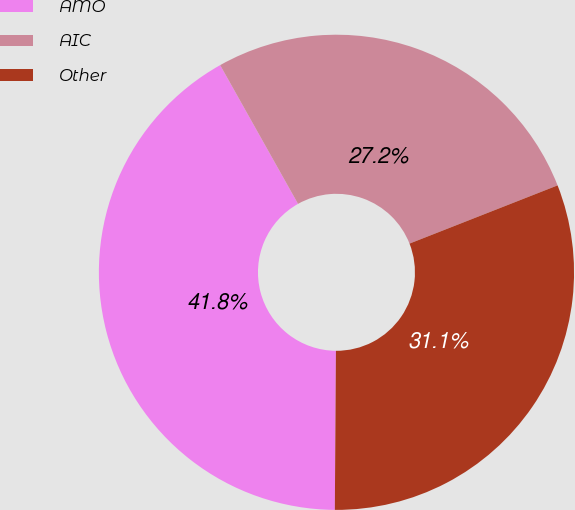Convert chart. <chart><loc_0><loc_0><loc_500><loc_500><pie_chart><fcel>AMO<fcel>AIC<fcel>Other<nl><fcel>41.75%<fcel>27.18%<fcel>31.07%<nl></chart> 